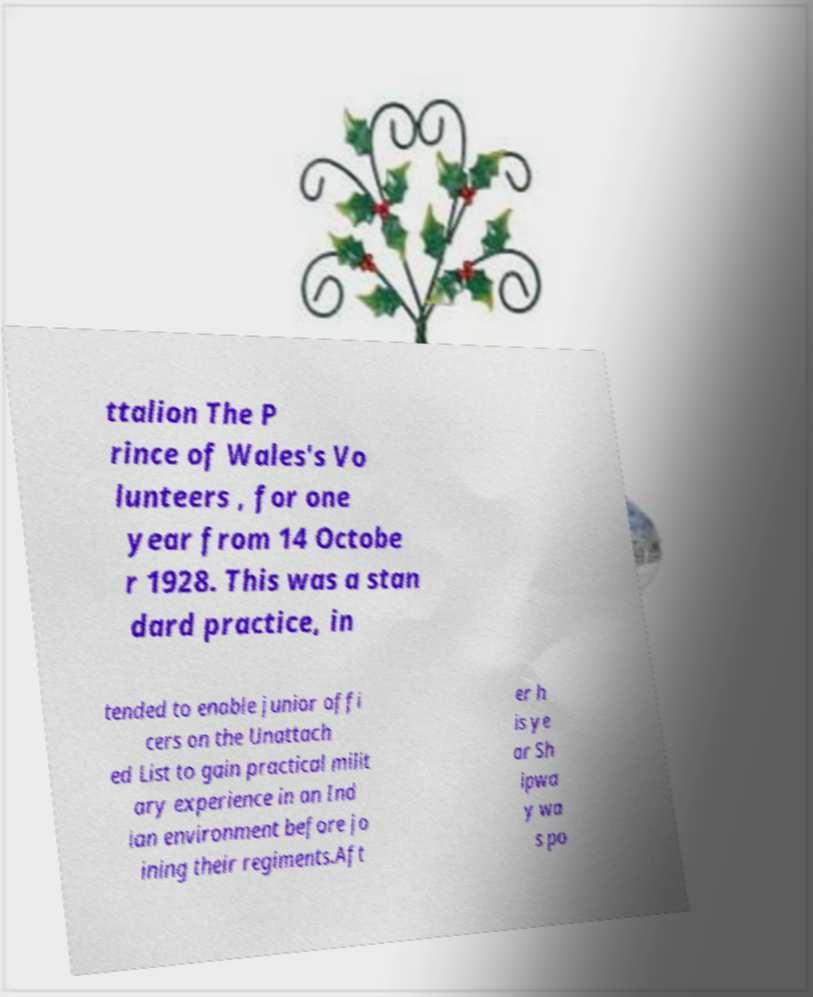Could you assist in decoding the text presented in this image and type it out clearly? ttalion The P rince of Wales's Vo lunteers , for one year from 14 Octobe r 1928. This was a stan dard practice, in tended to enable junior offi cers on the Unattach ed List to gain practical milit ary experience in an Ind ian environment before jo ining their regiments.Aft er h is ye ar Sh ipwa y wa s po 